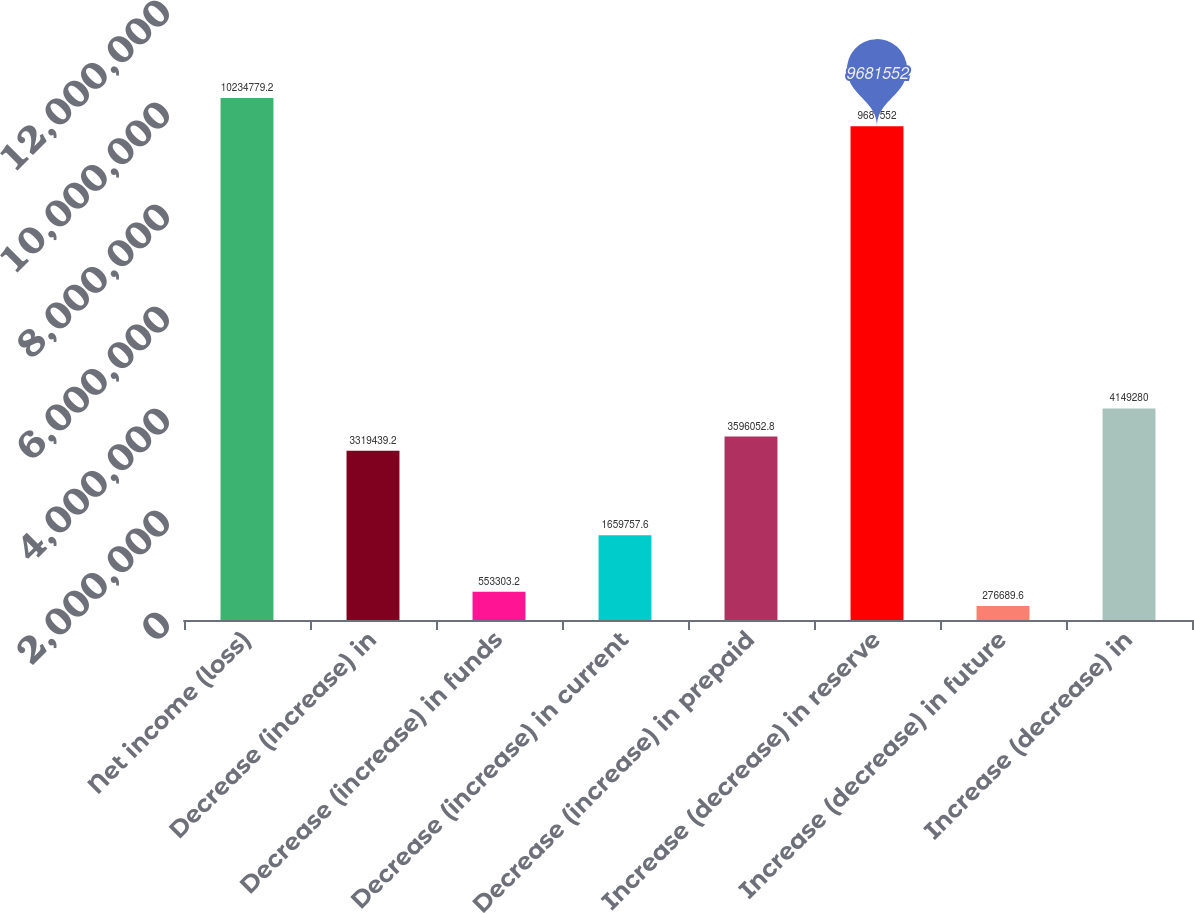Convert chart to OTSL. <chart><loc_0><loc_0><loc_500><loc_500><bar_chart><fcel>Net income (loss)<fcel>Decrease (increase) in<fcel>Decrease (increase) in funds<fcel>Decrease (increase) in current<fcel>Decrease (increase) in prepaid<fcel>Increase (decrease) in reserve<fcel>Increase (decrease) in future<fcel>Increase (decrease) in<nl><fcel>1.02348e+07<fcel>3.31944e+06<fcel>553303<fcel>1.65976e+06<fcel>3.59605e+06<fcel>9.68155e+06<fcel>276690<fcel>4.14928e+06<nl></chart> 